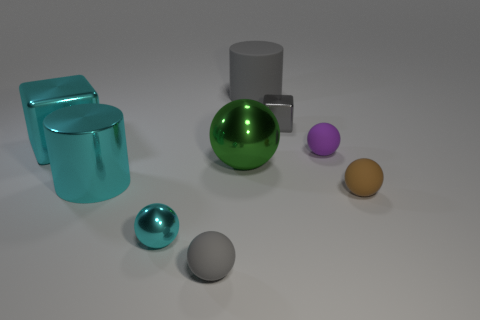Subtract all purple rubber spheres. How many spheres are left? 4 Add 1 tiny green matte cubes. How many objects exist? 10 Subtract all cyan balls. How many balls are left? 4 Subtract 3 balls. How many balls are left? 2 Subtract all cylinders. How many objects are left? 7 Subtract all blue spheres. How many cyan cubes are left? 1 Subtract all big yellow cylinders. Subtract all gray objects. How many objects are left? 6 Add 2 gray cylinders. How many gray cylinders are left? 3 Add 7 tiny purple balls. How many tiny purple balls exist? 8 Subtract 0 brown cubes. How many objects are left? 9 